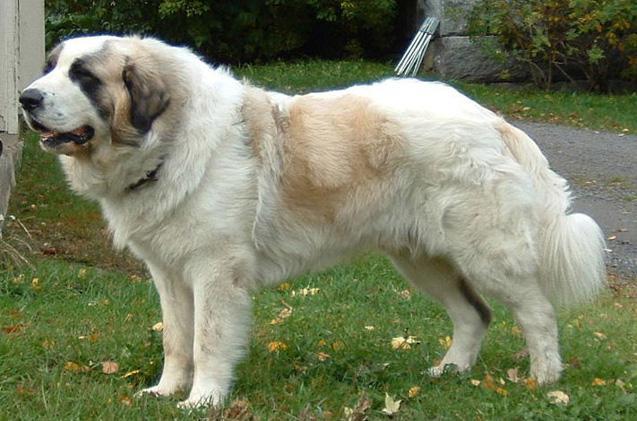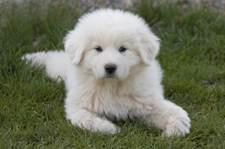The first image is the image on the left, the second image is the image on the right. Assess this claim about the two images: "One of the images features a single dog laying on grass.". Correct or not? Answer yes or no. Yes. 